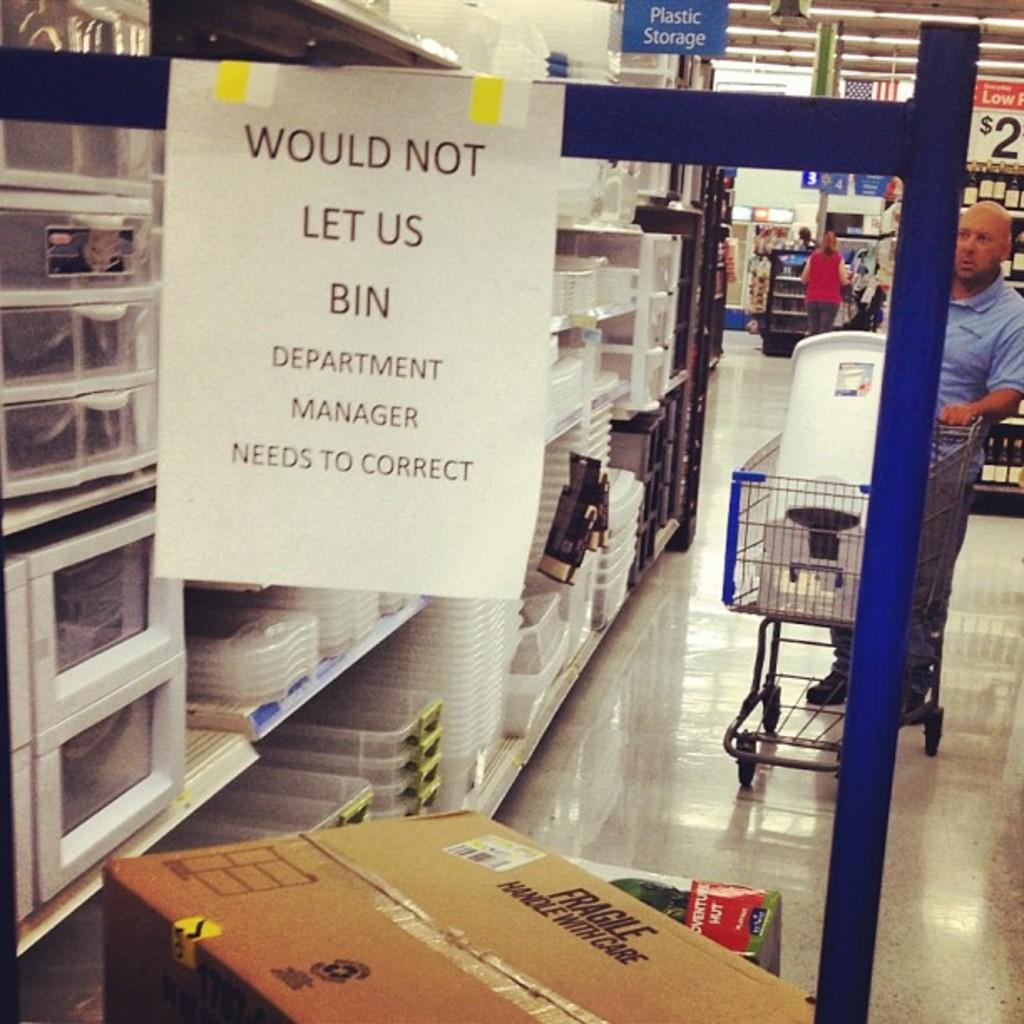<image>
Give a short and clear explanation of the subsequent image. A blue bar with a post on it that reads Would Not Let Us Bin on it. 